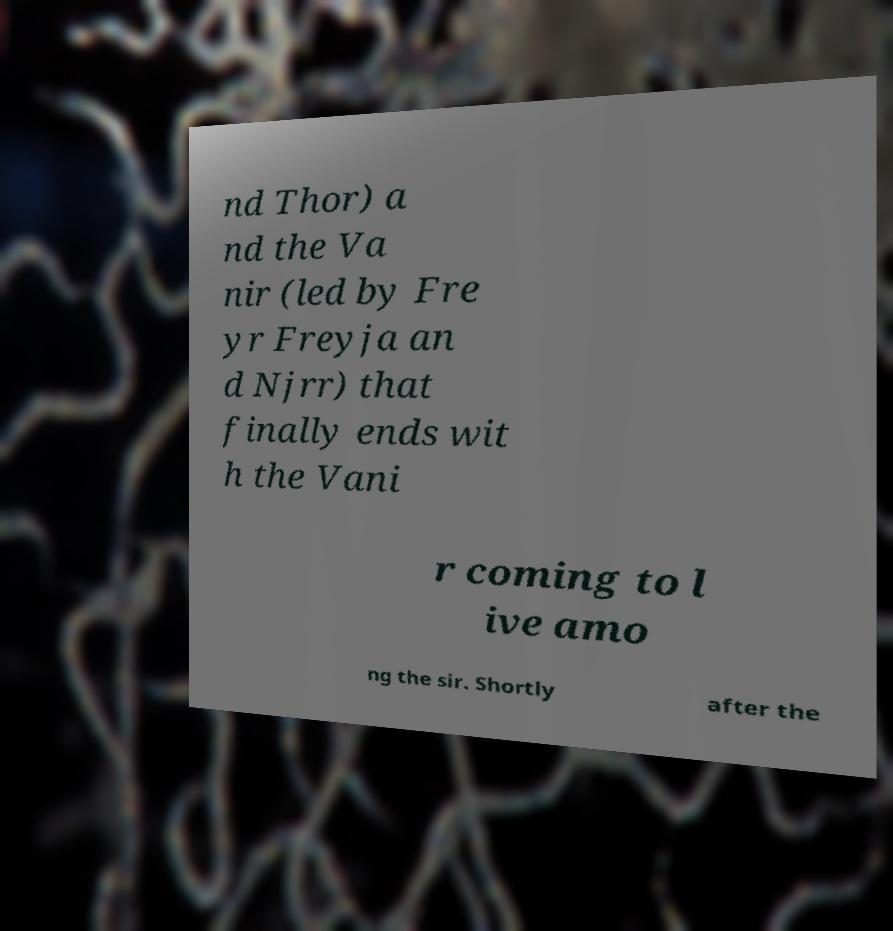Could you assist in decoding the text presented in this image and type it out clearly? nd Thor) a nd the Va nir (led by Fre yr Freyja an d Njrr) that finally ends wit h the Vani r coming to l ive amo ng the sir. Shortly after the 